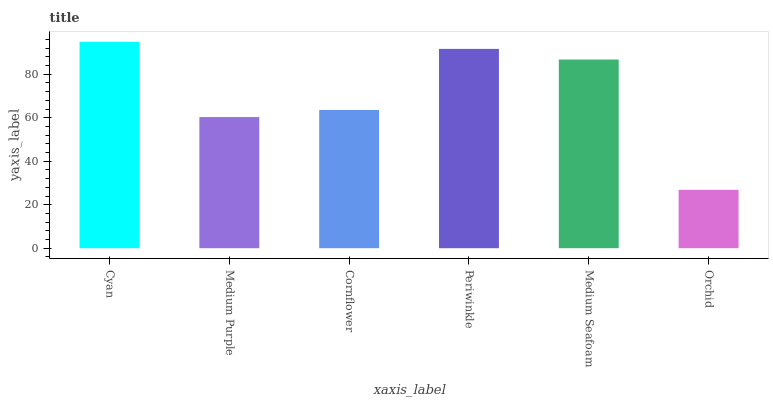Is Orchid the minimum?
Answer yes or no. Yes. Is Cyan the maximum?
Answer yes or no. Yes. Is Medium Purple the minimum?
Answer yes or no. No. Is Medium Purple the maximum?
Answer yes or no. No. Is Cyan greater than Medium Purple?
Answer yes or no. Yes. Is Medium Purple less than Cyan?
Answer yes or no. Yes. Is Medium Purple greater than Cyan?
Answer yes or no. No. Is Cyan less than Medium Purple?
Answer yes or no. No. Is Medium Seafoam the high median?
Answer yes or no. Yes. Is Cornflower the low median?
Answer yes or no. Yes. Is Orchid the high median?
Answer yes or no. No. Is Periwinkle the low median?
Answer yes or no. No. 